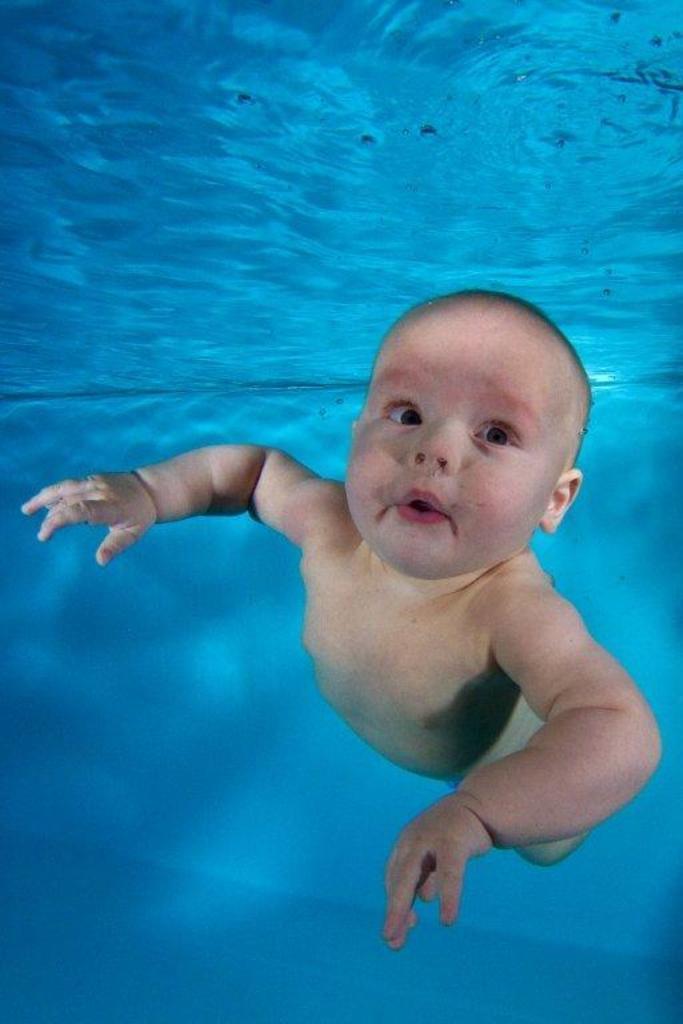Please provide a concise description of this image. In this picture I can see the inside view of water and I see a baby in front. 